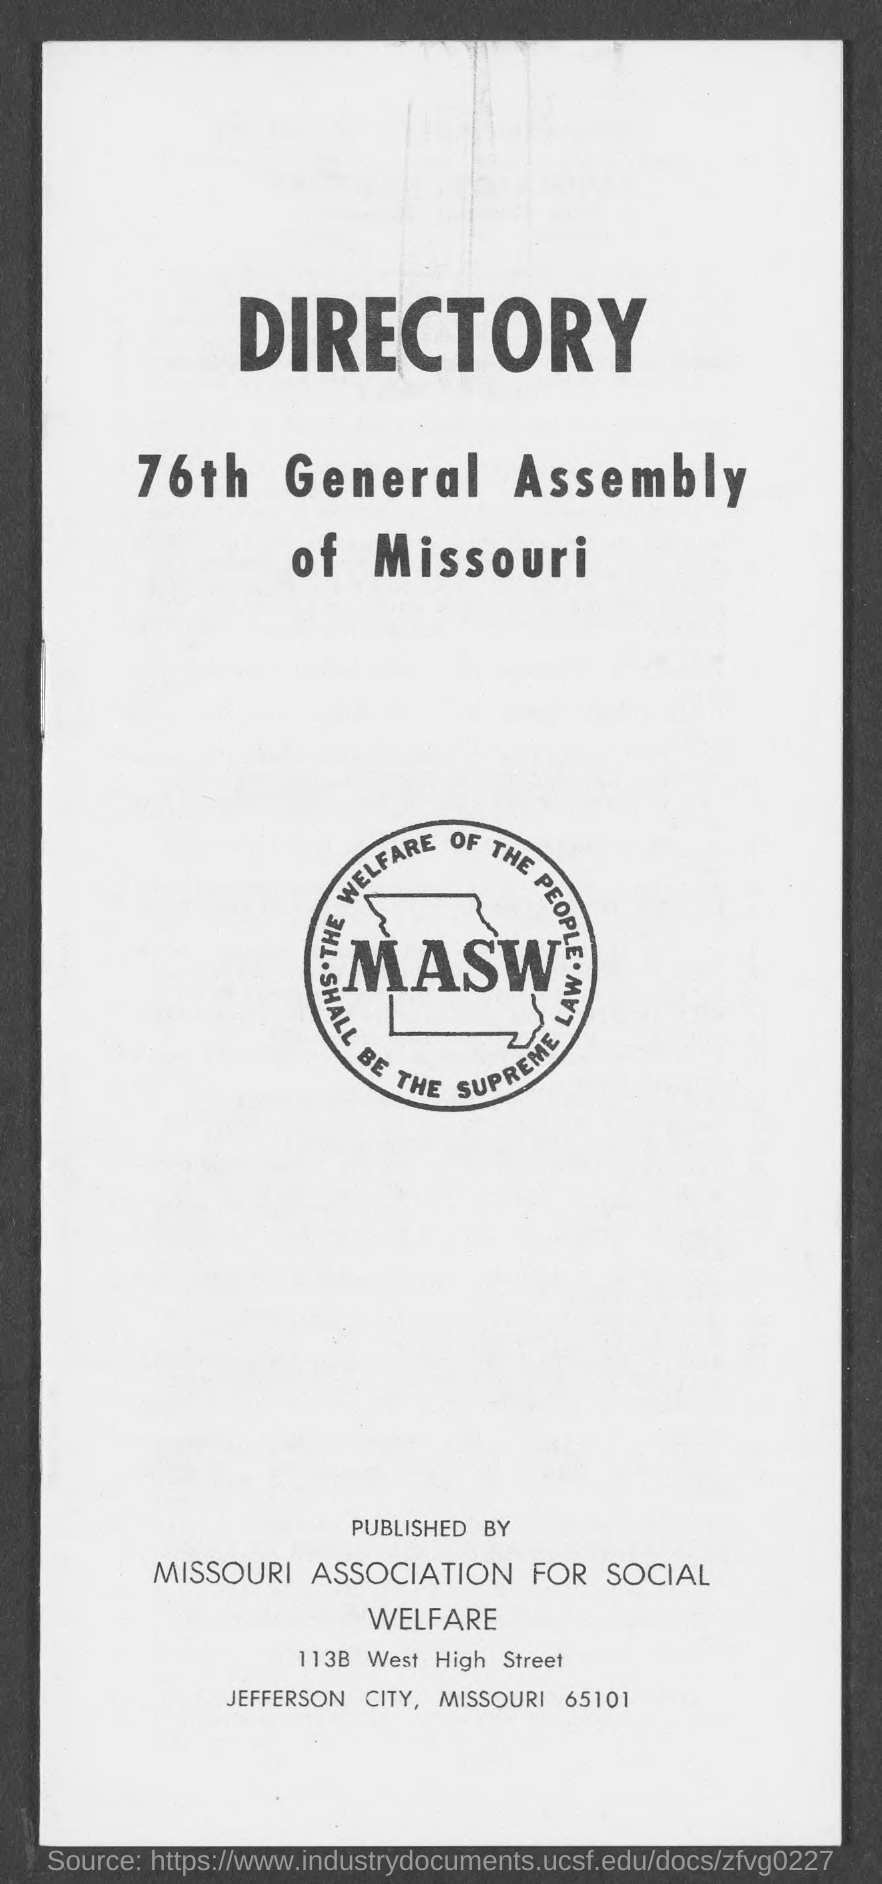The general assembly is of which state?
Offer a terse response. MISSOURI. Who is the publisher?
Your answer should be compact. MISSOURI ASSOCIATION FOR SOCIAL WELFARE. 